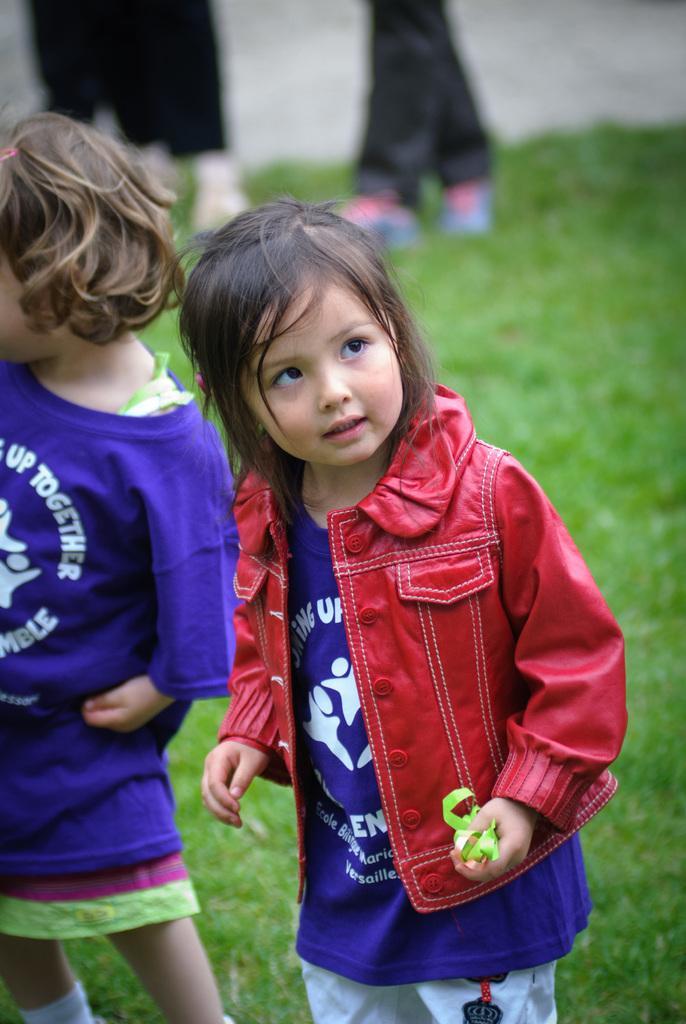How would you summarize this image in a sentence or two? In this picture there are two kids standing on a greenery ground and there are legs of two other persons standing in the background. 